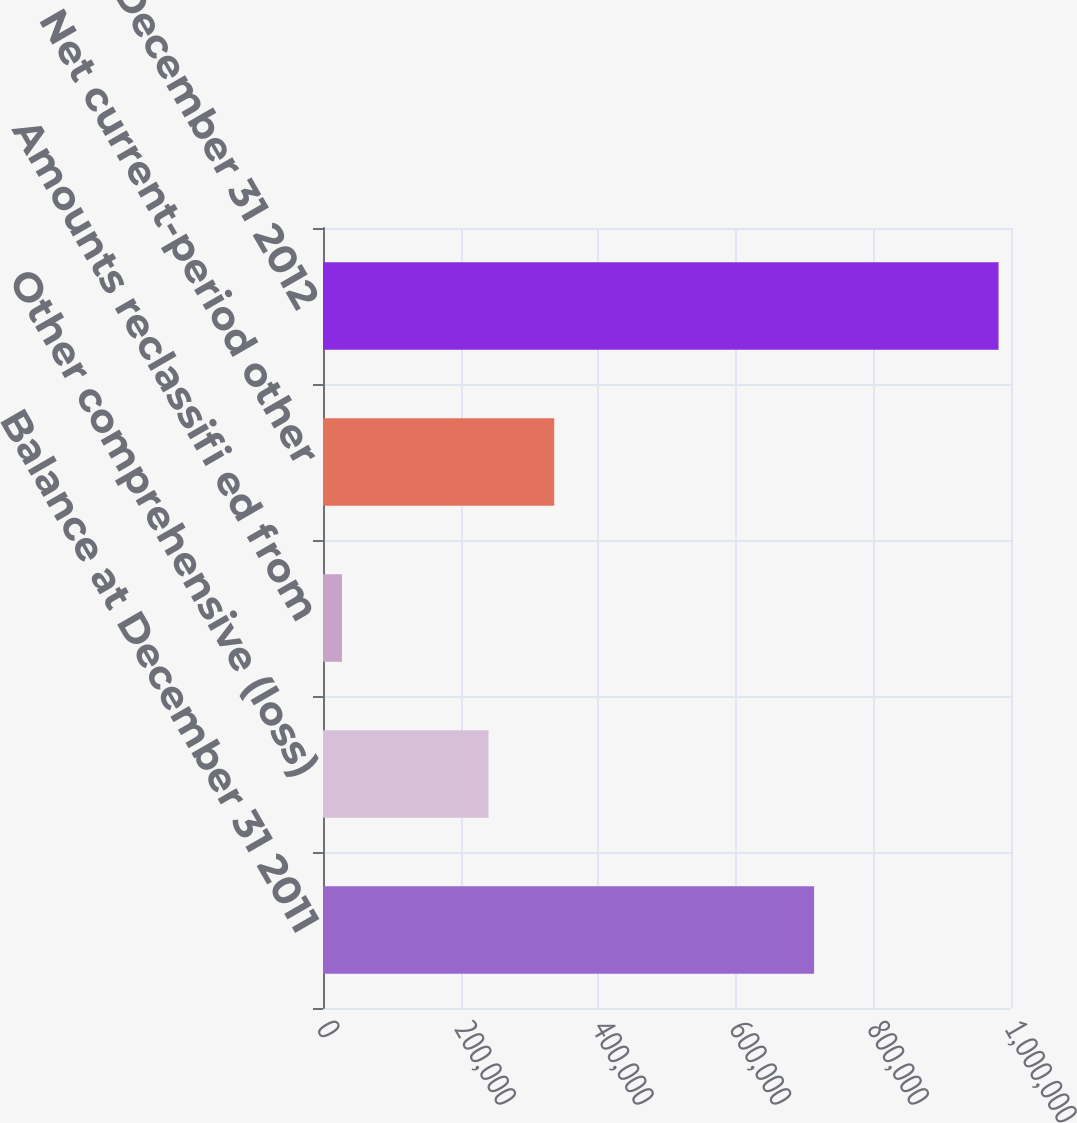<chart> <loc_0><loc_0><loc_500><loc_500><bar_chart><fcel>Balance at December 31 2011<fcel>Other comprehensive (loss)<fcel>Amounts reclassifi ed from<fcel>Net current-period other<fcel>Balance at December 31 2012<nl><fcel>713773<fcel>240603<fcel>27503<fcel>336041<fcel>981879<nl></chart> 